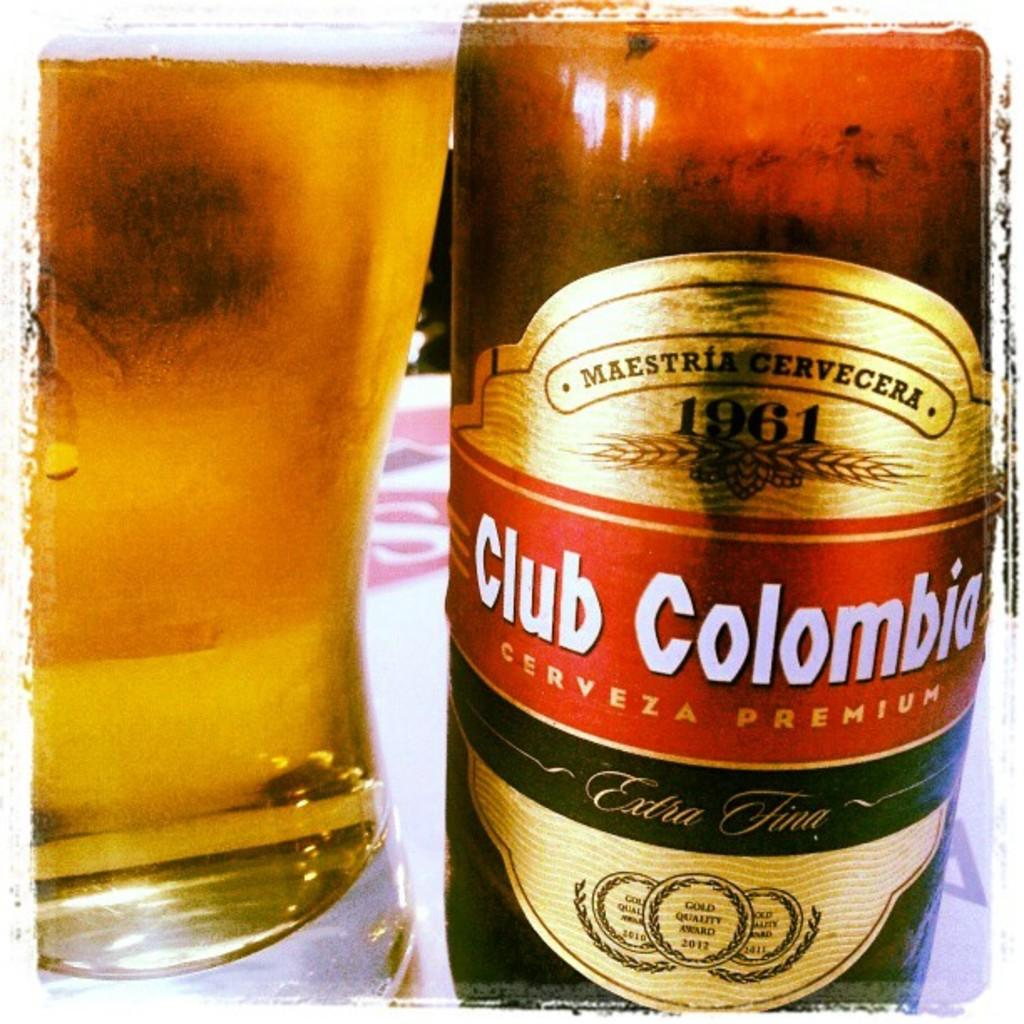<image>
Relay a brief, clear account of the picture shown. a glass of beer is sitting next to a bottle of Club Colombia beer on the table. 